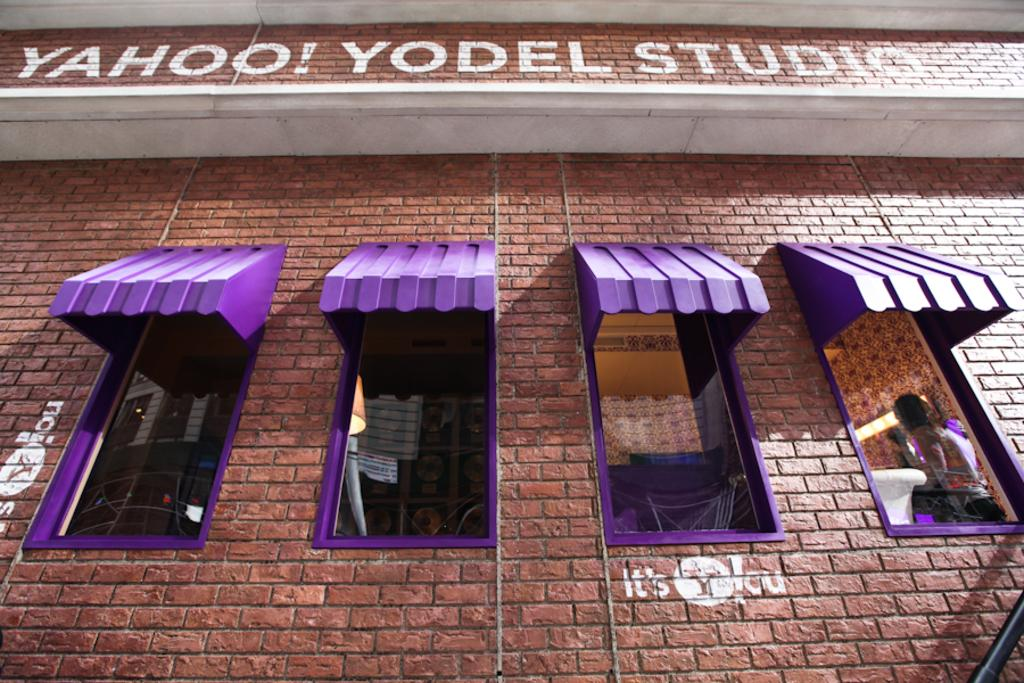What type of structure can be seen in the image? There is a brick wall in the image. What architectural feature is present in the brick wall? There are glass windows in the image. What color are the window roofs in the image? The window roofs in the image are purple in color. Can you describe the person in the image? There is a person in the image, but no specific details about their appearance or actions are provided. What is written or depicted on the wall in the image? There is some text on the wall in the image. What type of card is being used by the person in the image? There is no card present in the image; only a person, a brick wall, glass windows, purple window roofs, and text on the wall are visible. What type of fruit is hanging from the window roofs in the image? There is no fruit present in the image; only a person, a brick wall, glass windows, purple window roofs, and text on the wall are visible. 